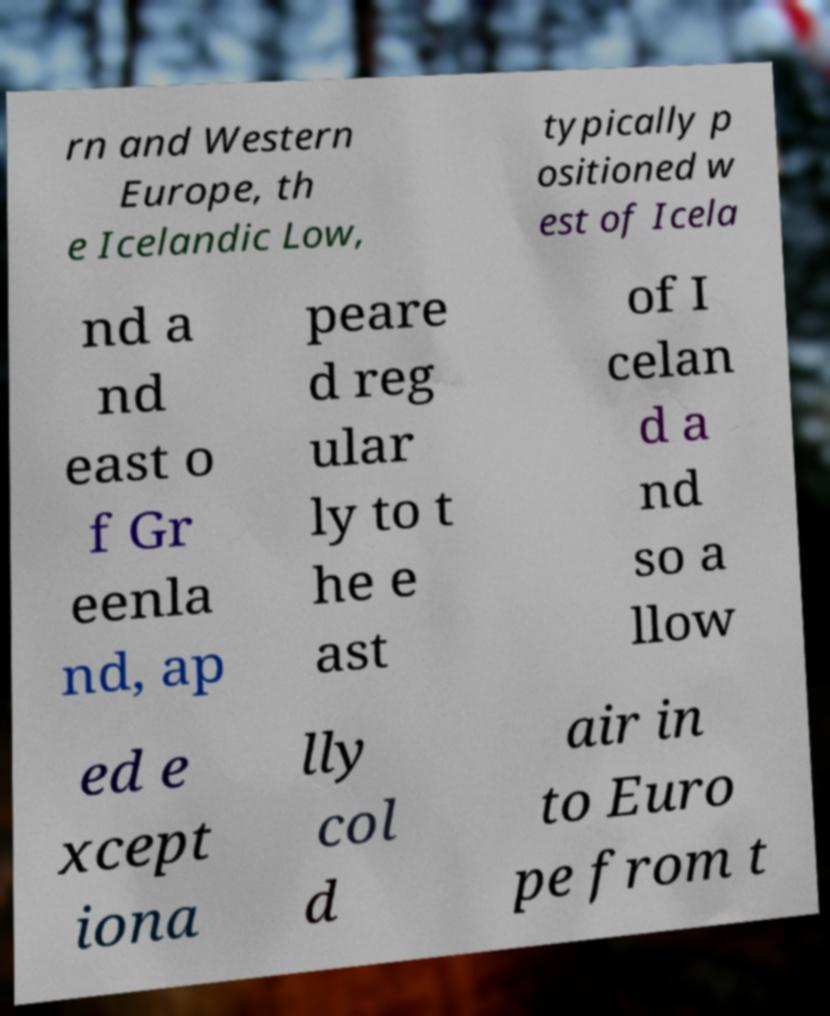What messages or text are displayed in this image? I need them in a readable, typed format. rn and Western Europe, th e Icelandic Low, typically p ositioned w est of Icela nd a nd east o f Gr eenla nd, ap peare d reg ular ly to t he e ast of I celan d a nd so a llow ed e xcept iona lly col d air in to Euro pe from t 